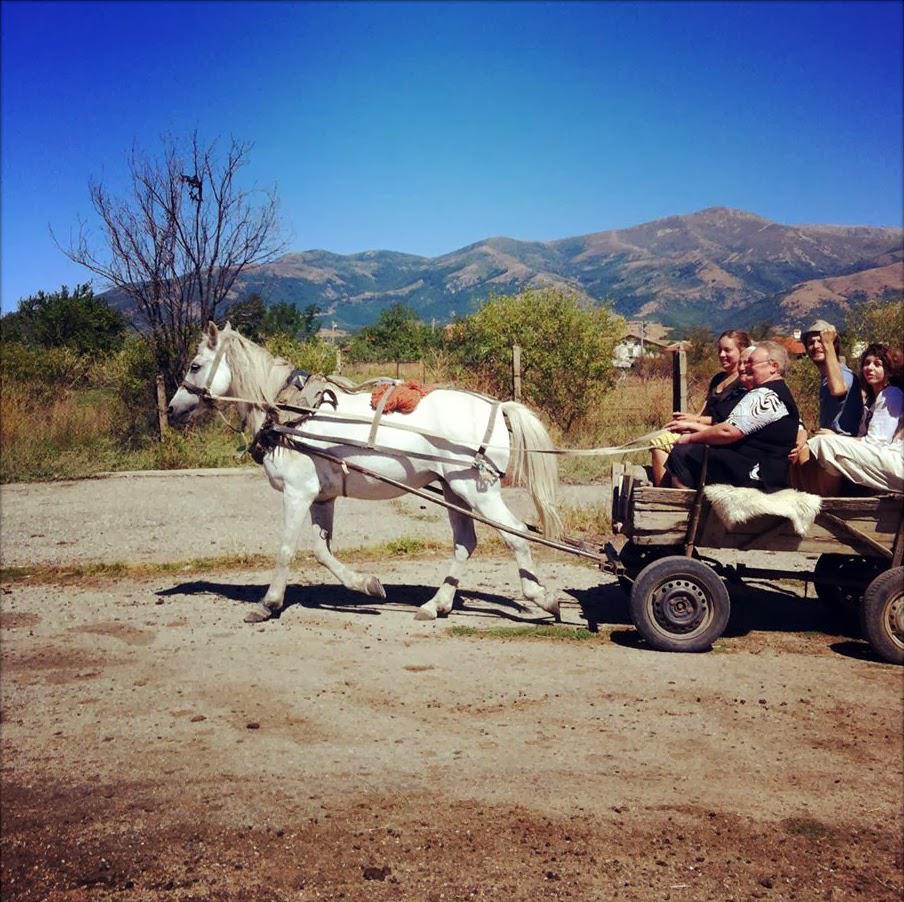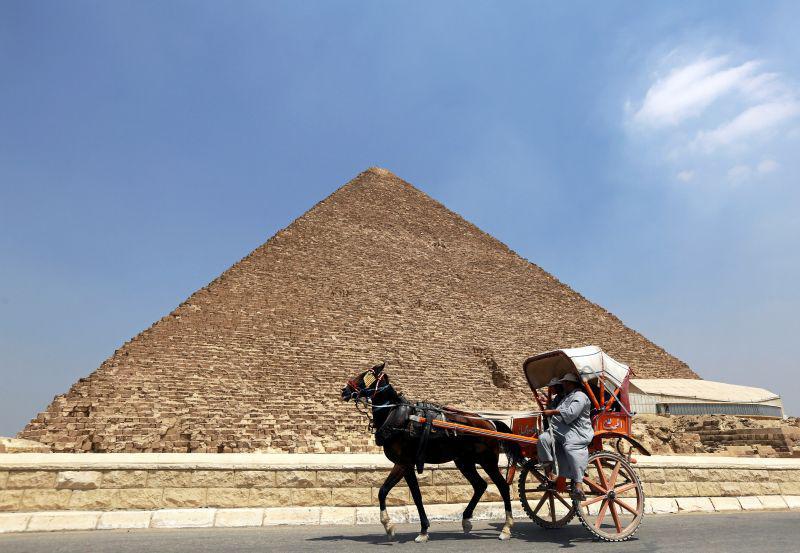The first image is the image on the left, the second image is the image on the right. For the images displayed, is the sentence "A white horse is pulling one of the carts." factually correct? Answer yes or no. Yes. The first image is the image on the left, the second image is the image on the right. For the images shown, is this caption "An image shows a four-wheeled horse-drawn wagon with some type of white canopy." true? Answer yes or no. No. 